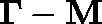<formula> <loc_0><loc_0><loc_500><loc_500>\Gamma - M</formula> 